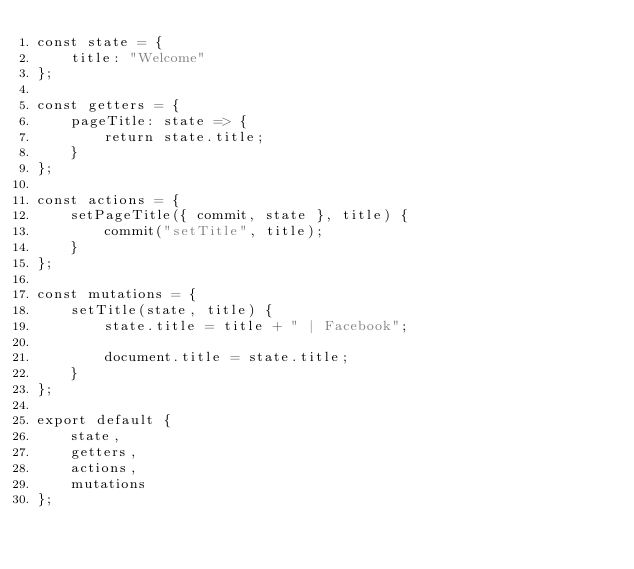<code> <loc_0><loc_0><loc_500><loc_500><_JavaScript_>const state = {
    title: "Welcome"
};

const getters = {
    pageTitle: state => {
        return state.title;
    }
};

const actions = {
    setPageTitle({ commit, state }, title) {
        commit("setTitle", title);
    }
};

const mutations = {
    setTitle(state, title) {
        state.title = title + " | Facebook";

        document.title = state.title;
    }
};

export default {
    state,
    getters,
    actions,
    mutations
};
</code> 